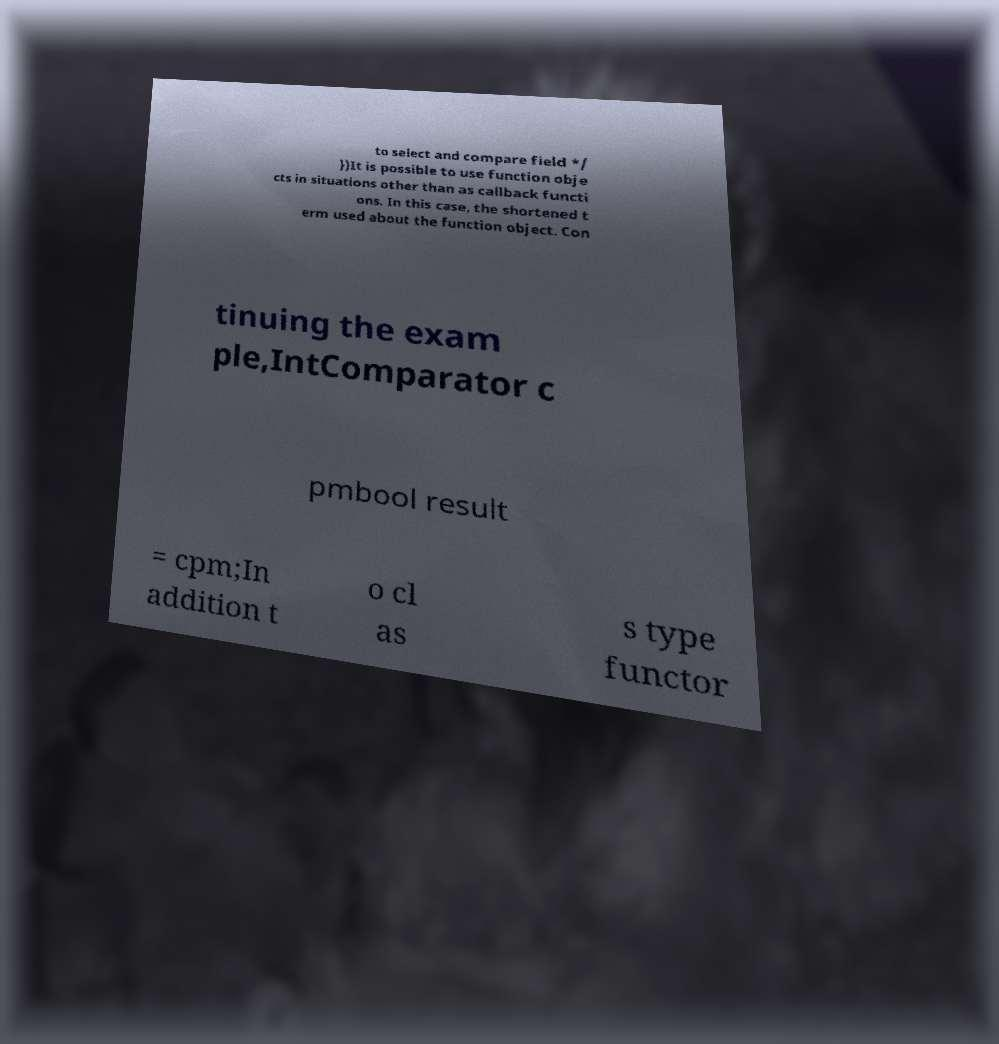Please identify and transcribe the text found in this image. to select and compare field */ })It is possible to use function obje cts in situations other than as callback functi ons. In this case, the shortened t erm used about the function object. Con tinuing the exam ple,IntComparator c pmbool result = cpm;In addition t o cl as s type functor 